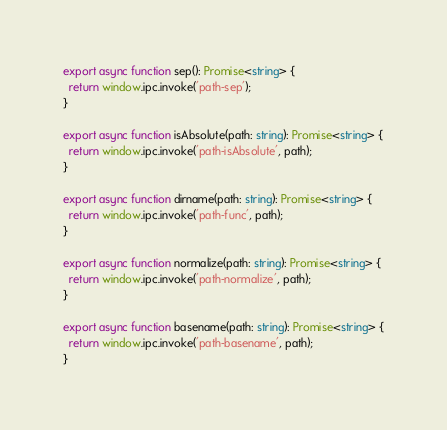<code> <loc_0><loc_0><loc_500><loc_500><_TypeScript_>export async function sep(): Promise<string> {
  return window.ipc.invoke('path-sep');
}

export async function isAbsolute(path: string): Promise<string> {
  return window.ipc.invoke('path-isAbsolute', path);
}

export async function dirname(path: string): Promise<string> {
  return window.ipc.invoke('path-func', path);
}

export async function normalize(path: string): Promise<string> {
  return window.ipc.invoke('path-normalize', path);
}

export async function basename(path: string): Promise<string> {
  return window.ipc.invoke('path-basename', path);
}
</code> 